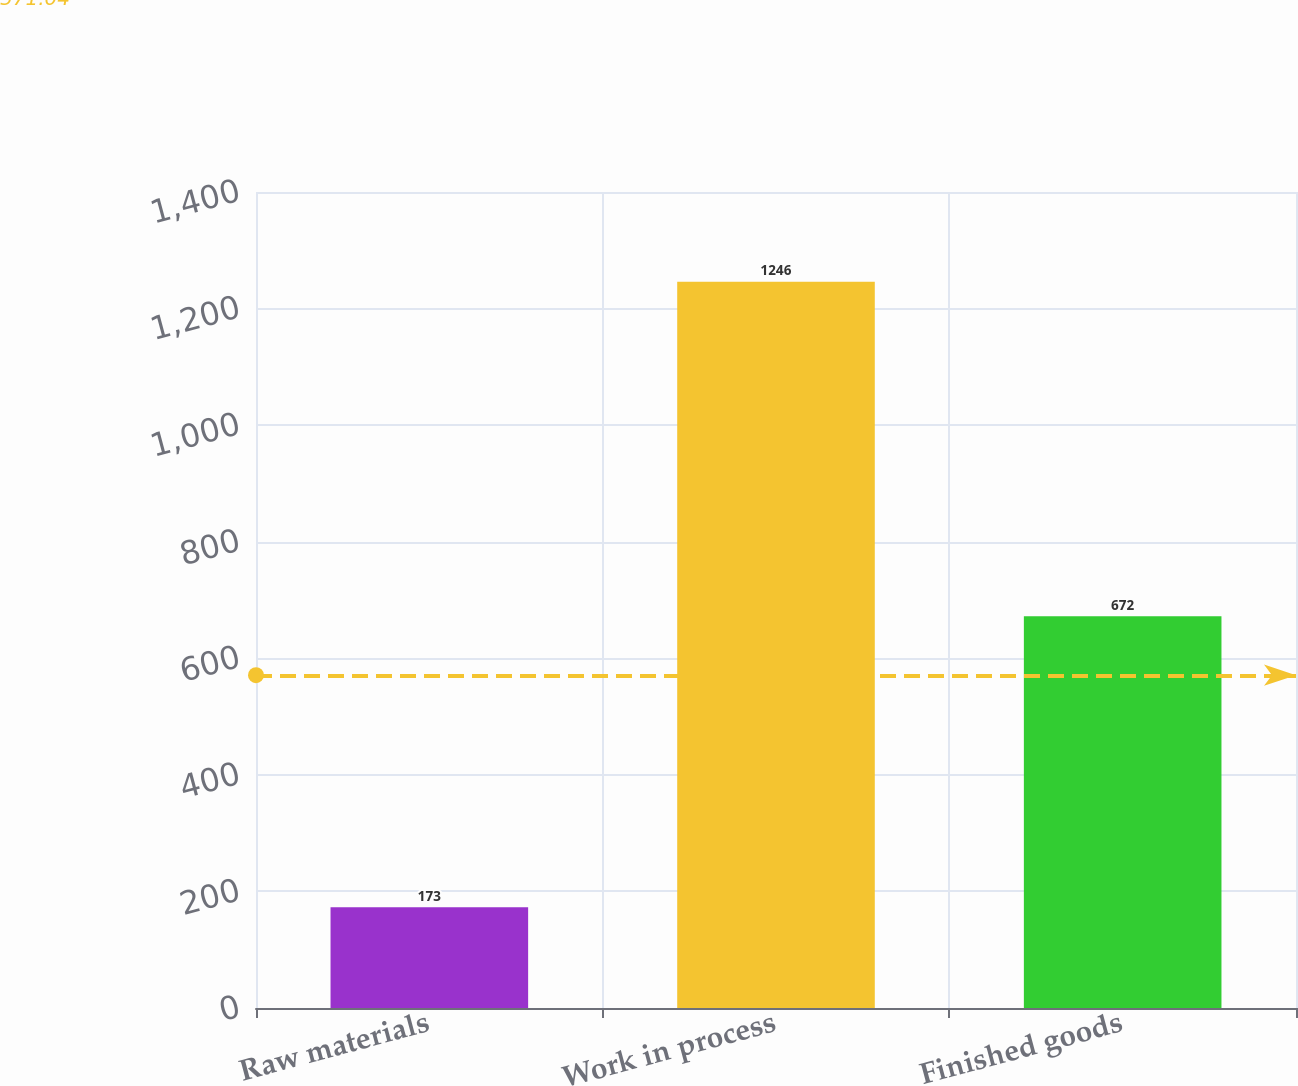Convert chart to OTSL. <chart><loc_0><loc_0><loc_500><loc_500><bar_chart><fcel>Raw materials<fcel>Work in process<fcel>Finished goods<nl><fcel>173<fcel>1246<fcel>672<nl></chart> 